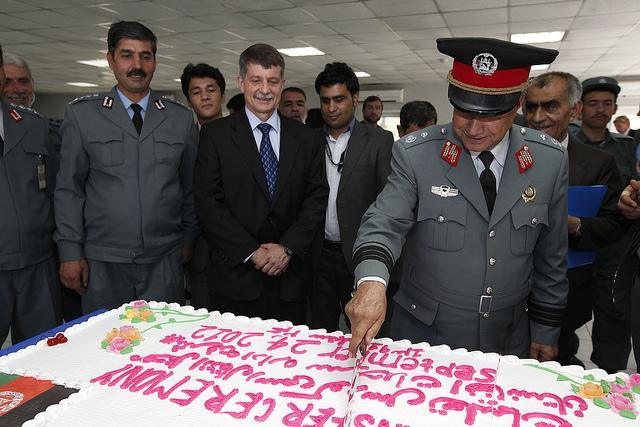Why is the man reaching towards the cake? Please explain your reasoning. to cut. This is a celebration and he has a knife in his hand 